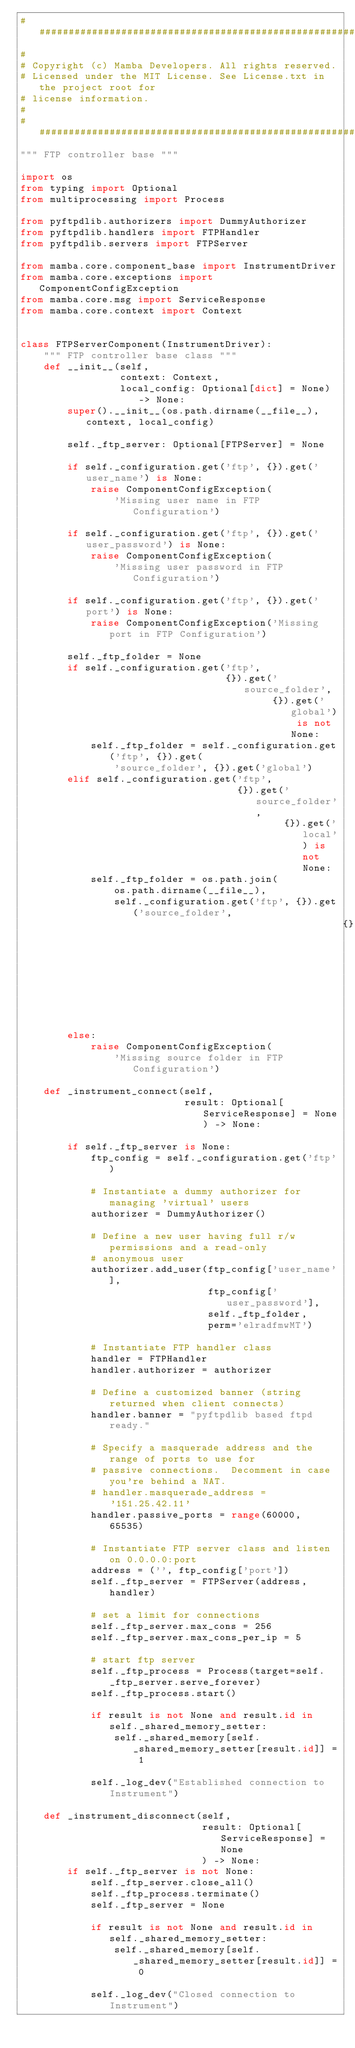<code> <loc_0><loc_0><loc_500><loc_500><_Python_>############################################################################
#
# Copyright (c) Mamba Developers. All rights reserved.
# Licensed under the MIT License. See License.txt in the project root for
# license information.
#
############################################################################
""" FTP controller base """

import os
from typing import Optional
from multiprocessing import Process

from pyftpdlib.authorizers import DummyAuthorizer
from pyftpdlib.handlers import FTPHandler
from pyftpdlib.servers import FTPServer

from mamba.core.component_base import InstrumentDriver
from mamba.core.exceptions import ComponentConfigException
from mamba.core.msg import ServiceResponse
from mamba.core.context import Context


class FTPServerComponent(InstrumentDriver):
    """ FTP controller base class """
    def __init__(self,
                 context: Context,
                 local_config: Optional[dict] = None) -> None:
        super().__init__(os.path.dirname(__file__), context, local_config)

        self._ftp_server: Optional[FTPServer] = None

        if self._configuration.get('ftp', {}).get('user_name') is None:
            raise ComponentConfigException(
                'Missing user name in FTP Configuration')

        if self._configuration.get('ftp', {}).get('user_password') is None:
            raise ComponentConfigException(
                'Missing user password in FTP Configuration')

        if self._configuration.get('ftp', {}).get('port') is None:
            raise ComponentConfigException('Missing port in FTP Configuration')

        self._ftp_folder = None
        if self._configuration.get('ftp',
                                   {}).get('source_folder',
                                           {}).get('global') is not None:
            self._ftp_folder = self._configuration.get('ftp', {}).get(
                'source_folder', {}).get('global')
        elif self._configuration.get('ftp',
                                     {}).get('source_folder',
                                             {}).get('local') is not None:
            self._ftp_folder = os.path.join(
                os.path.dirname(__file__),
                self._configuration.get('ftp', {}).get('source_folder',
                                                       {}).get('local'))
        else:
            raise ComponentConfigException(
                'Missing source folder in FTP Configuration')

    def _instrument_connect(self,
                            result: Optional[ServiceResponse] = None) -> None:

        if self._ftp_server is None:
            ftp_config = self._configuration.get('ftp')

            # Instantiate a dummy authorizer for managing 'virtual' users
            authorizer = DummyAuthorizer()

            # Define a new user having full r/w permissions and a read-only
            # anonymous user
            authorizer.add_user(ftp_config['user_name'],
                                ftp_config['user_password'],
                                self._ftp_folder,
                                perm='elradfmwMT')

            # Instantiate FTP handler class
            handler = FTPHandler
            handler.authorizer = authorizer

            # Define a customized banner (string returned when client connects)
            handler.banner = "pyftpdlib based ftpd ready."

            # Specify a masquerade address and the range of ports to use for
            # passive connections.  Decomment in case you're behind a NAT.
            # handler.masquerade_address = '151.25.42.11'
            handler.passive_ports = range(60000, 65535)

            # Instantiate FTP server class and listen on 0.0.0.0:port
            address = ('', ftp_config['port'])
            self._ftp_server = FTPServer(address, handler)

            # set a limit for connections
            self._ftp_server.max_cons = 256
            self._ftp_server.max_cons_per_ip = 5

            # start ftp server
            self._ftp_process = Process(target=self._ftp_server.serve_forever)
            self._ftp_process.start()

            if result is not None and result.id in self._shared_memory_setter:
                self._shared_memory[self._shared_memory_setter[result.id]] = 1

            self._log_dev("Established connection to Instrument")

    def _instrument_disconnect(self,
                               result: Optional[ServiceResponse] = None
                               ) -> None:
        if self._ftp_server is not None:
            self._ftp_server.close_all()
            self._ftp_process.terminate()
            self._ftp_server = None

            if result is not None and result.id in self._shared_memory_setter:
                self._shared_memory[self._shared_memory_setter[result.id]] = 0

            self._log_dev("Closed connection to Instrument")
</code> 